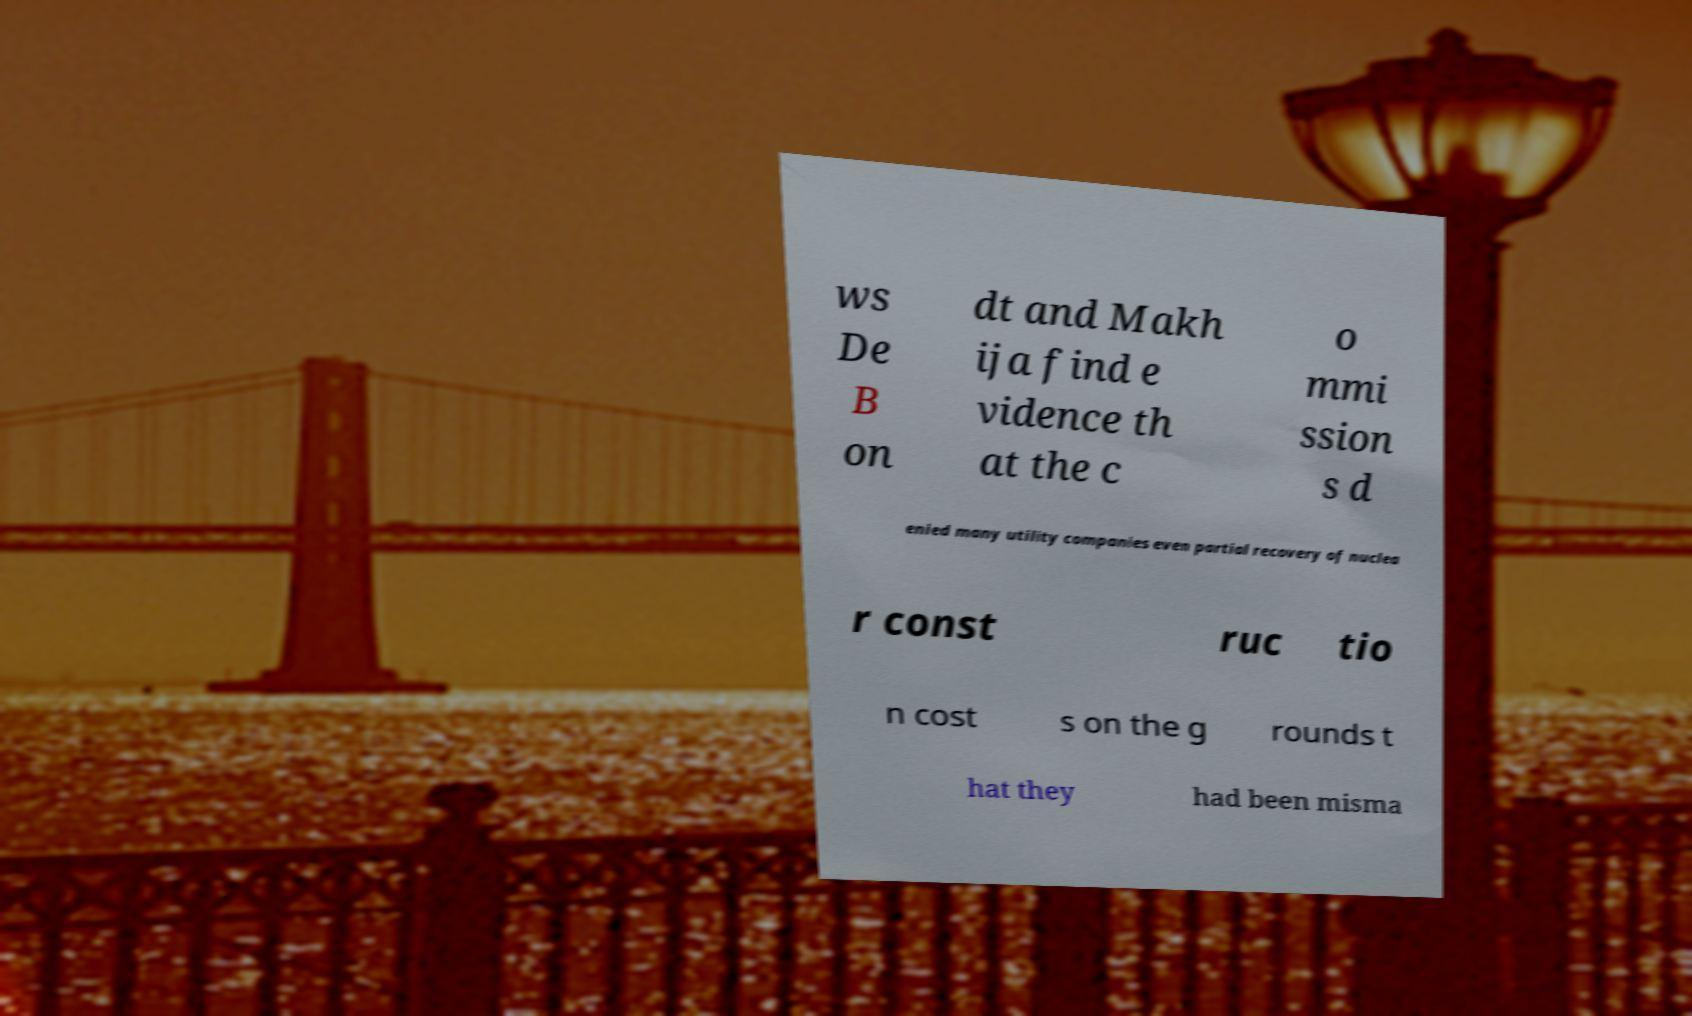For documentation purposes, I need the text within this image transcribed. Could you provide that? ws De B on dt and Makh ija find e vidence th at the c o mmi ssion s d enied many utility companies even partial recovery of nuclea r const ruc tio n cost s on the g rounds t hat they had been misma 